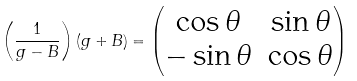Convert formula to latex. <formula><loc_0><loc_0><loc_500><loc_500>\left ( \frac { 1 } { g - B } \right ) ( g + B ) = \begin{pmatrix} \cos \theta & \sin \theta \\ - \sin \theta & \cos \theta \end{pmatrix}</formula> 